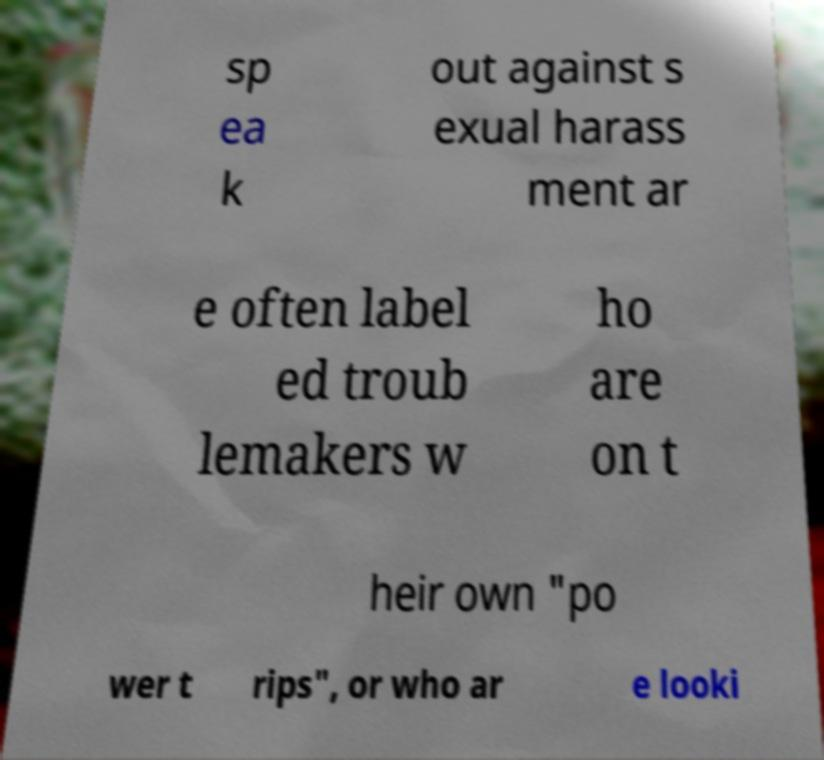Could you assist in decoding the text presented in this image and type it out clearly? sp ea k out against s exual harass ment ar e often label ed troub lemakers w ho are on t heir own "po wer t rips", or who ar e looki 